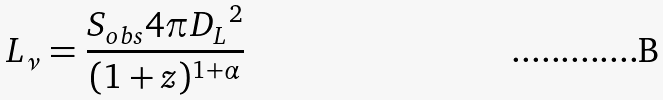<formula> <loc_0><loc_0><loc_500><loc_500>L _ { \nu } = \frac { S _ { o b s } 4 \pi { D _ { L } } ^ { 2 } } { ( 1 + z ) ^ { 1 + \alpha } }</formula> 